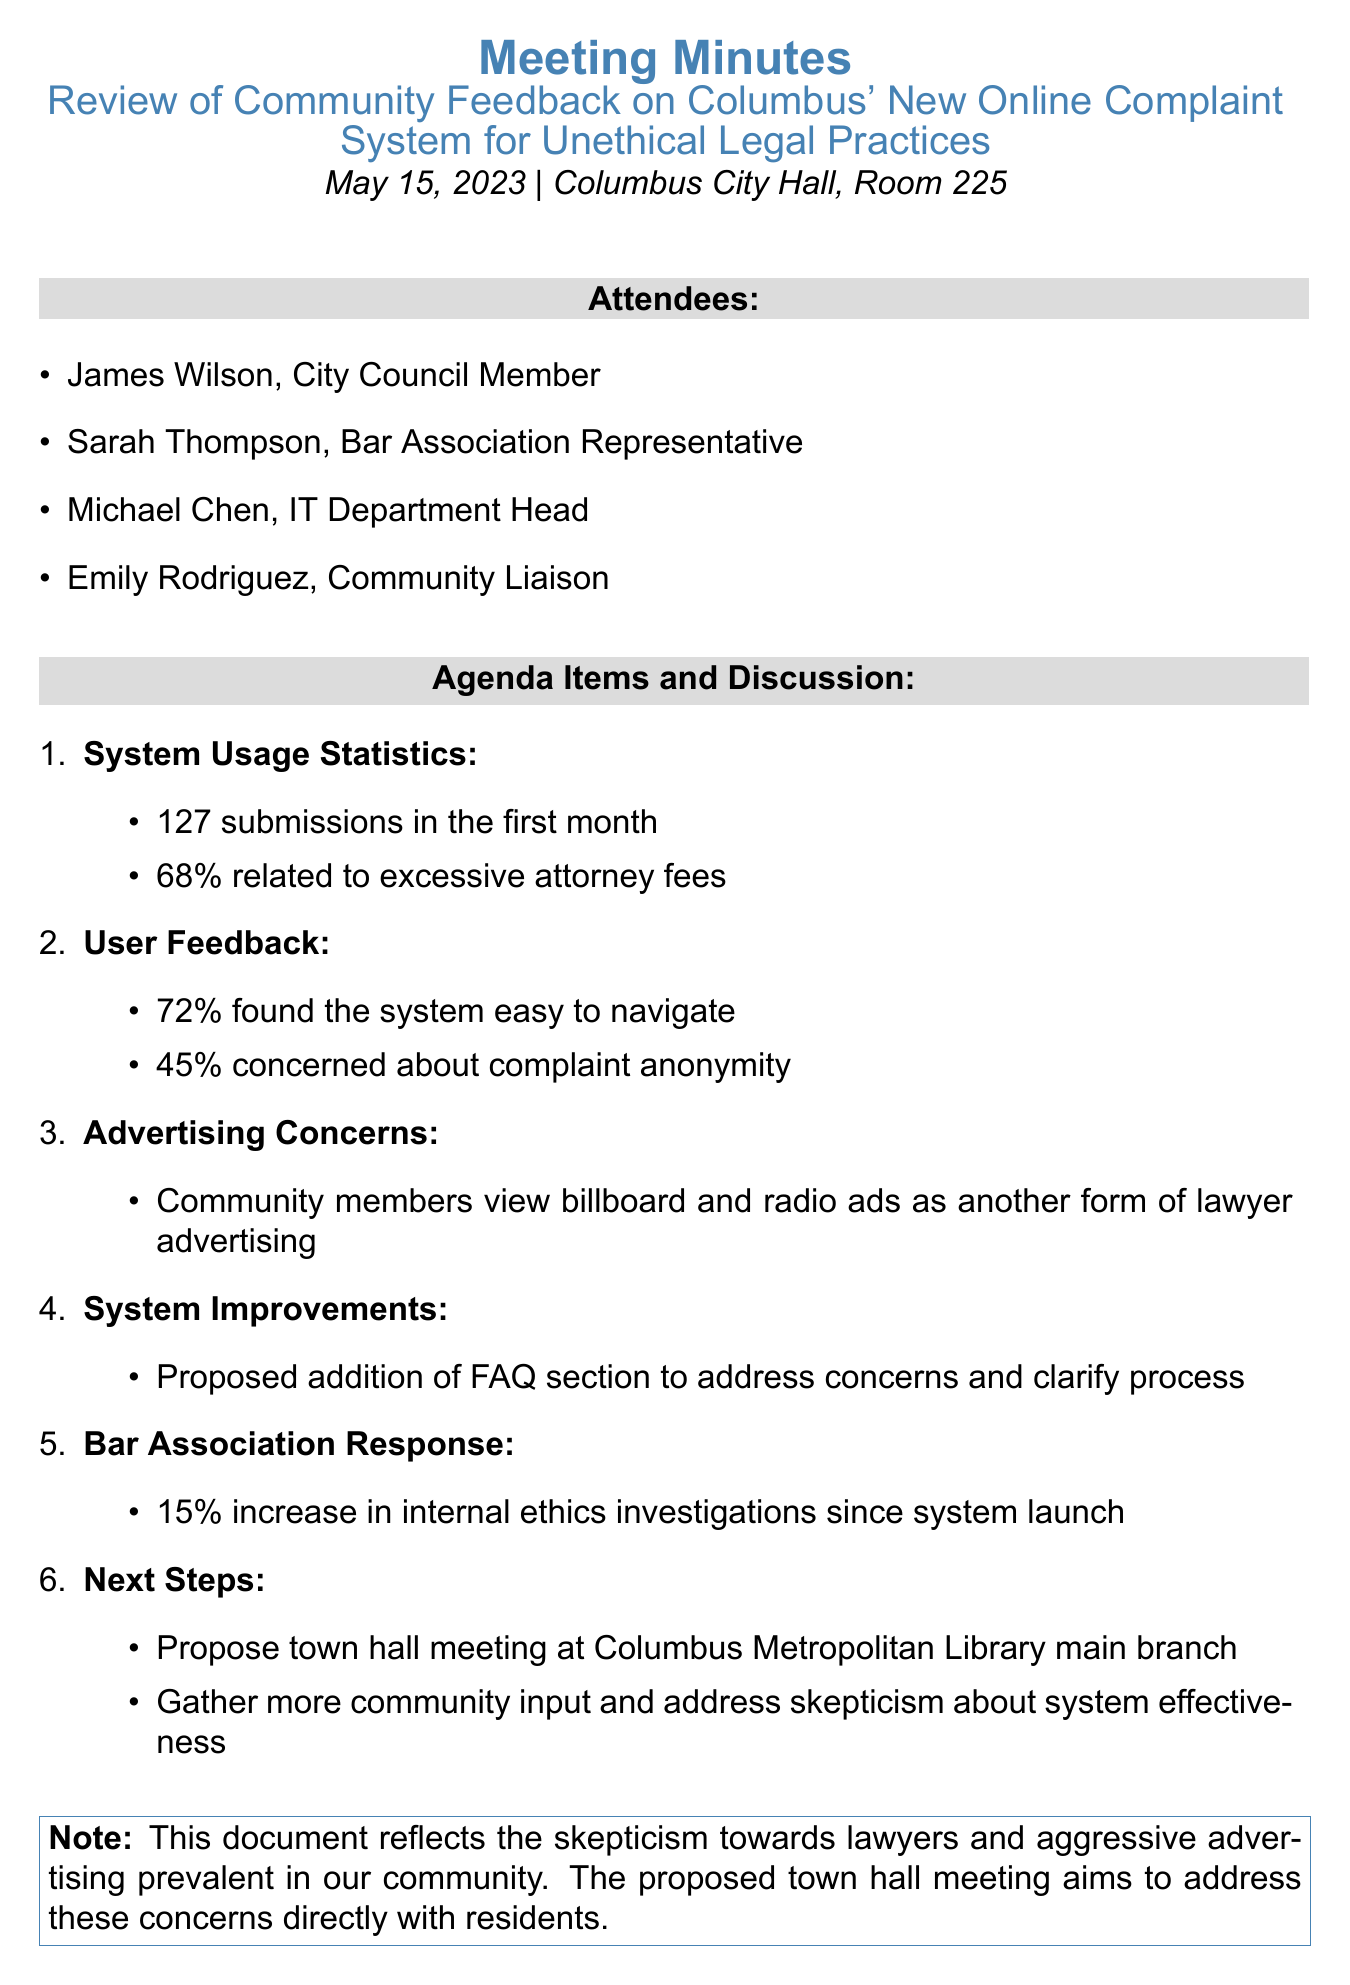What was the date of the meeting? The date of the meeting is mentioned in the document as May 15, 2023.
Answer: May 15, 2023 How many submissions did the online complaint system receive in its first month? The document states that the online complaint system received 127 submissions in its first month.
Answer: 127 What percentage of complaints were related to excessive attorney fees? The document indicates that 68% of the complaints were related to excessive attorney fees.
Answer: 68% What improvement does the IT department propose for the complaint system? The IT department proposes adding a FAQ section to address common concerns.
Answer: FAQ section What was the reported increase in internal ethics investigations since the system's launch? The document specifies that the Bar Association reports a 15% increase in internal ethics investigations.
Answer: 15% Why do community members raise concerns about advertisements for the system? Community members view the advertisements on billboards and radio as another form of lawyer advertising.
Answer: Another form of lawyer advertising What is the purpose of the proposed town hall meeting? The town hall meeting aims to gather more community input and address skepticism about the system's effectiveness.
Answer: Gather more community input What percentage of users found the online complaint system easy to navigate? The document mentions that 72% of users found the system easy to navigate.
Answer: 72% 